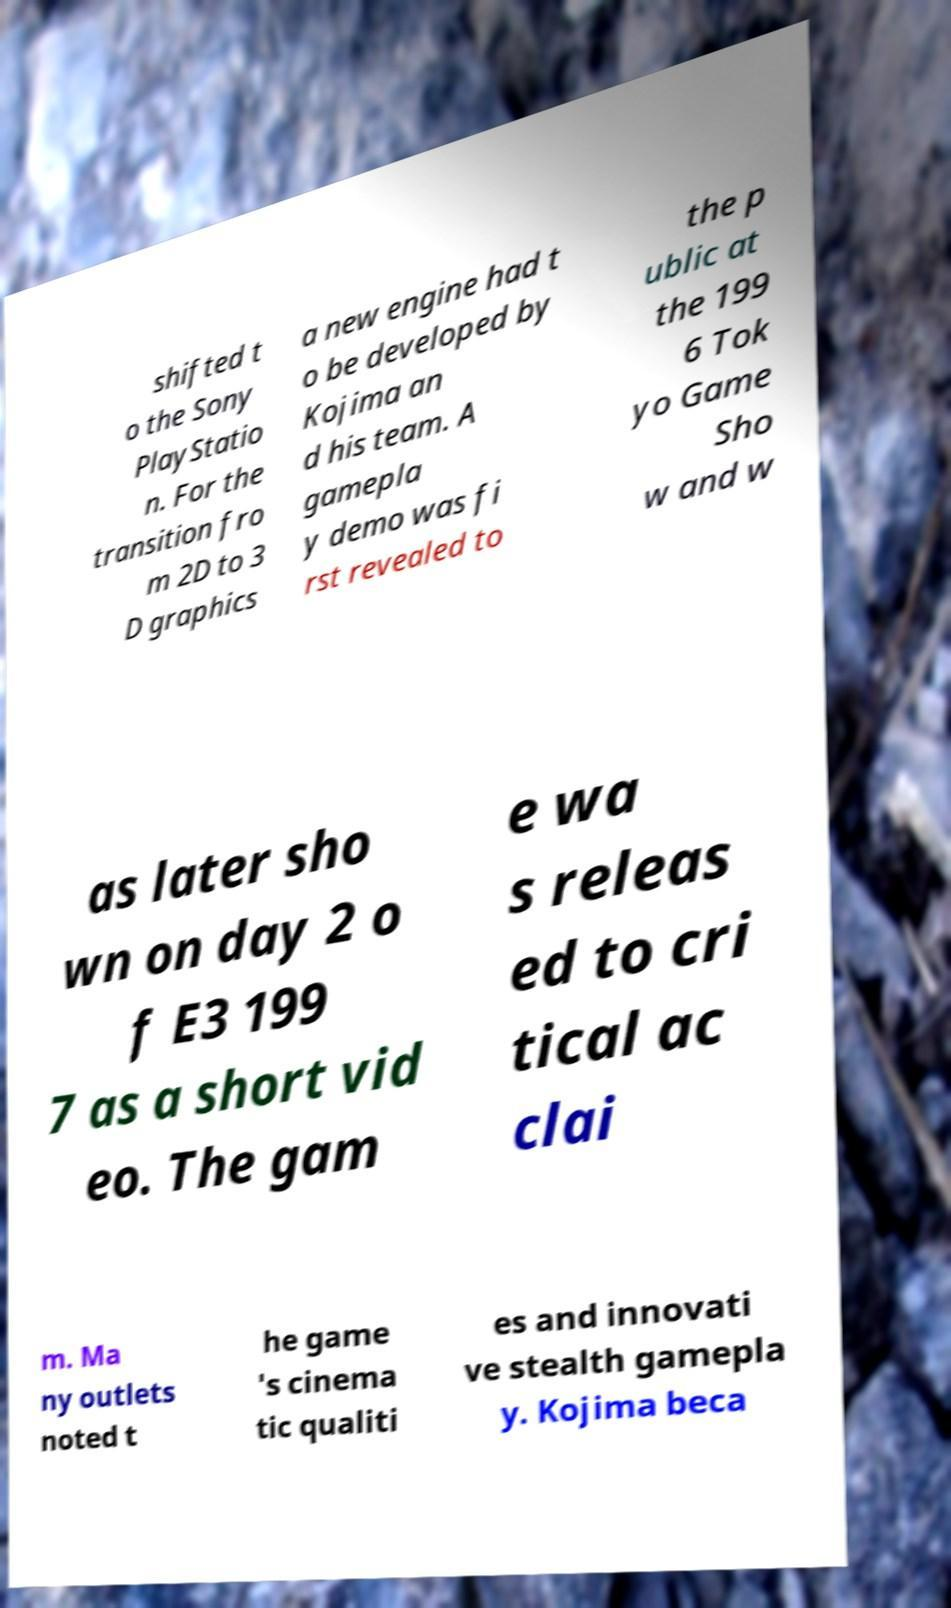Can you read and provide the text displayed in the image?This photo seems to have some interesting text. Can you extract and type it out for me? shifted t o the Sony PlayStatio n. For the transition fro m 2D to 3 D graphics a new engine had t o be developed by Kojima an d his team. A gamepla y demo was fi rst revealed to the p ublic at the 199 6 Tok yo Game Sho w and w as later sho wn on day 2 o f E3 199 7 as a short vid eo. The gam e wa s releas ed to cri tical ac clai m. Ma ny outlets noted t he game 's cinema tic qualiti es and innovati ve stealth gamepla y. Kojima beca 